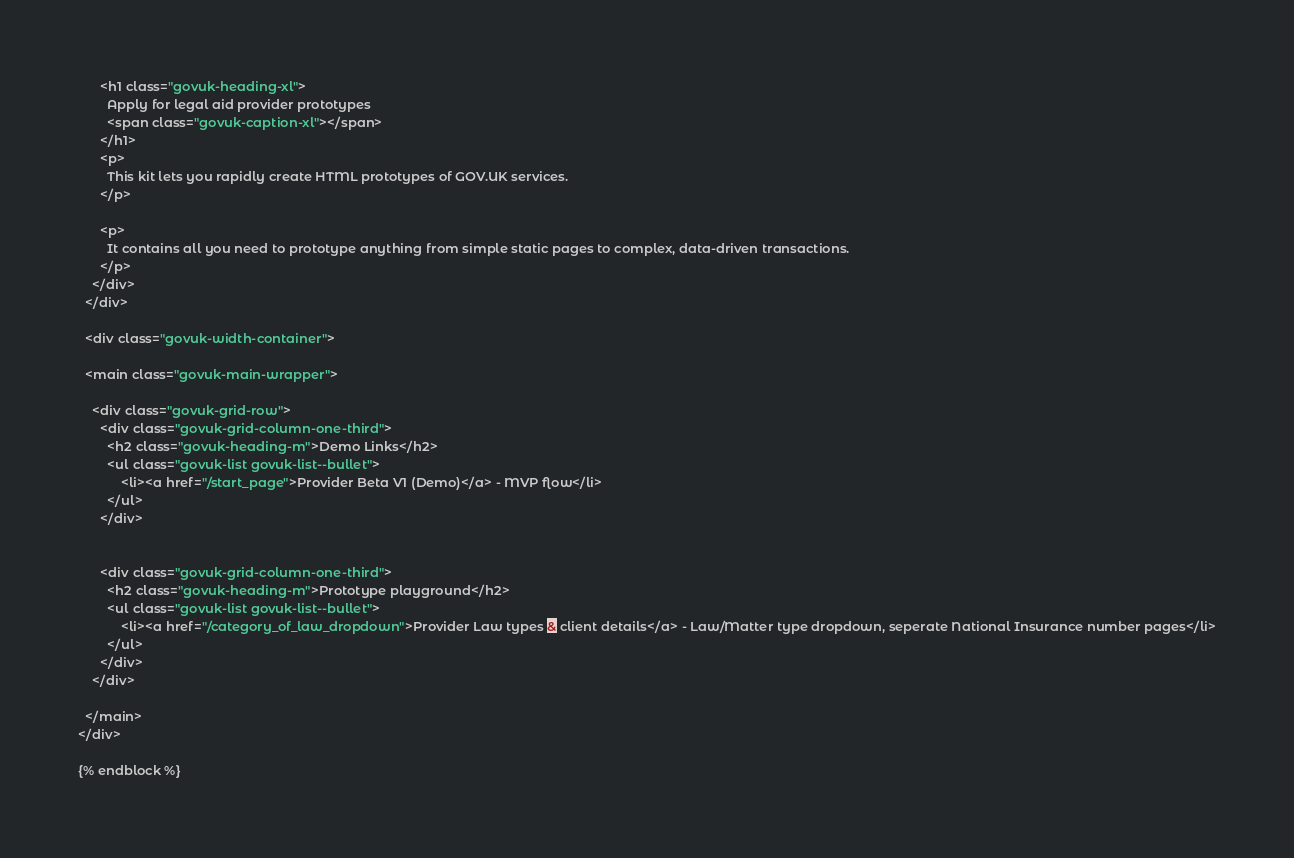<code> <loc_0><loc_0><loc_500><loc_500><_HTML_>      <h1 class="govuk-heading-xl">
        Apply for legal aid provider prototypes
        <span class="govuk-caption-xl"></span>
      </h1>
      <p>
        This kit lets you rapidly create HTML prototypes of GOV.UK services.
      </p>

      <p>
        It contains all you need to prototype anything from simple static pages to complex, data-driven transactions.
      </p>
    </div>
  </div>

  <div class="govuk-width-container">

  <main class="govuk-main-wrapper">

    <div class="govuk-grid-row">
      <div class="govuk-grid-column-one-third">
        <h2 class="govuk-heading-m">Demo Links</h2>
        <ul class="govuk-list govuk-list--bullet">
        	<li><a href="/start_page">Provider Beta V1 (Demo)</a> - MVP flow</li>
        </ul>
      </div>


      <div class="govuk-grid-column-one-third">
        <h2 class="govuk-heading-m">Prototype playground</h2>
        <ul class="govuk-list govuk-list--bullet">
        	<li><a href="/category_of_law_dropdown">Provider Law types & client details</a> - Law/Matter type dropdown, seperate National Insurance number pages</li>
        </ul>
      </div>
    </div>

  </main>
</div>

{% endblock %}
</code> 